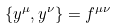<formula> <loc_0><loc_0><loc_500><loc_500>\{ y ^ { \mu } , y ^ { \nu } \} = f ^ { \mu \nu }</formula> 